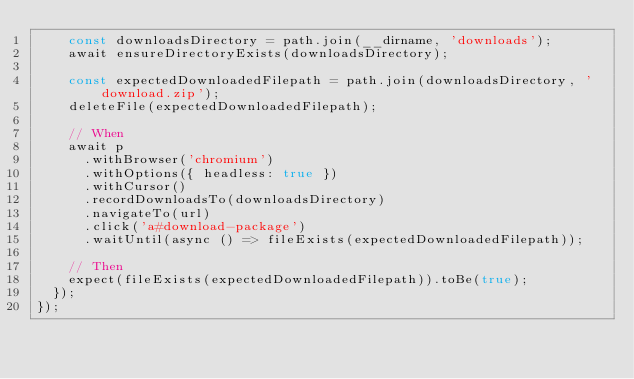Convert code to text. <code><loc_0><loc_0><loc_500><loc_500><_TypeScript_>    const downloadsDirectory = path.join(__dirname, 'downloads');
    await ensureDirectoryExists(downloadsDirectory);

    const expectedDownloadedFilepath = path.join(downloadsDirectory, 'download.zip');
    deleteFile(expectedDownloadedFilepath);

    // When
    await p
      .withBrowser('chromium')
      .withOptions({ headless: true })
      .withCursor()
      .recordDownloadsTo(downloadsDirectory)
      .navigateTo(url)
      .click('a#download-package')
      .waitUntil(async () => fileExists(expectedDownloadedFilepath));

    // Then
    expect(fileExists(expectedDownloadedFilepath)).toBe(true);
  });
});
</code> 